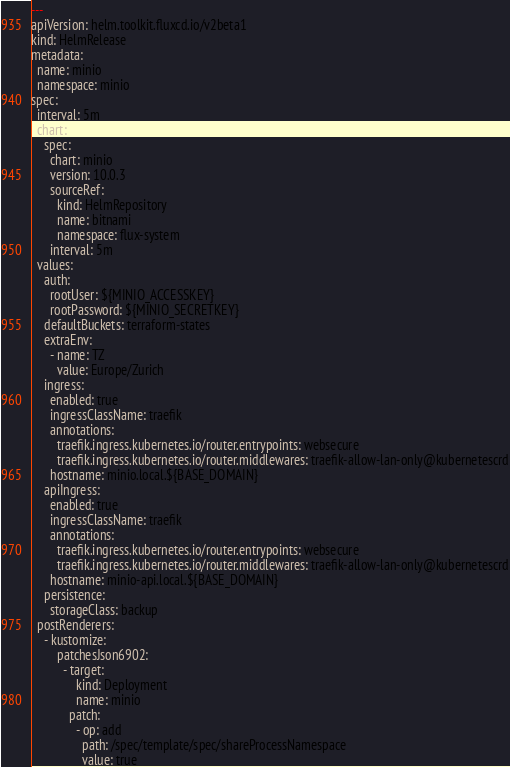Convert code to text. <code><loc_0><loc_0><loc_500><loc_500><_YAML_>---
apiVersion: helm.toolkit.fluxcd.io/v2beta1
kind: HelmRelease
metadata:
  name: minio
  namespace: minio
spec:
  interval: 5m
  chart:
    spec:
      chart: minio
      version: 10.0.3
      sourceRef:
        kind: HelmRepository
        name: bitnami
        namespace: flux-system
      interval: 5m
  values:
    auth:
      rootUser: ${MINIO_ACCESSKEY}
      rootPassword: ${MINIO_SECRETKEY}
    defaultBuckets: terraform-states
    extraEnv:
      - name: TZ
        value: Europe/Zurich
    ingress:
      enabled: true
      ingressClassName: traefik
      annotations:
        traefik.ingress.kubernetes.io/router.entrypoints: websecure
        traefik.ingress.kubernetes.io/router.middlewares: traefik-allow-lan-only@kubernetescrd
      hostname: minio.local.${BASE_DOMAIN}
    apiIngress:
      enabled: true
      ingressClassName: traefik
      annotations:
        traefik.ingress.kubernetes.io/router.entrypoints: websecure
        traefik.ingress.kubernetes.io/router.middlewares: traefik-allow-lan-only@kubernetescrd
      hostname: minio-api.local.${BASE_DOMAIN}
    persistence:
      storageClass: backup
  postRenderers:
    - kustomize:
        patchesJson6902:
          - target:
              kind: Deployment
              name: minio
            patch:
              - op: add
                path: /spec/template/spec/shareProcessNamespace
                value: true
</code> 